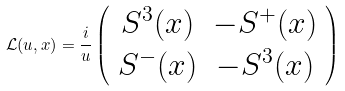<formula> <loc_0><loc_0><loc_500><loc_500>\mathcal { L } ( u , x ) = \frac { i } { u } \left ( \begin{array} { c c } S ^ { 3 } ( x ) & - S ^ { + } ( x ) \\ S ^ { - } ( x ) & - S ^ { 3 } ( x ) \end{array} \right )</formula> 